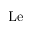<formula> <loc_0><loc_0><loc_500><loc_500>L e</formula> 